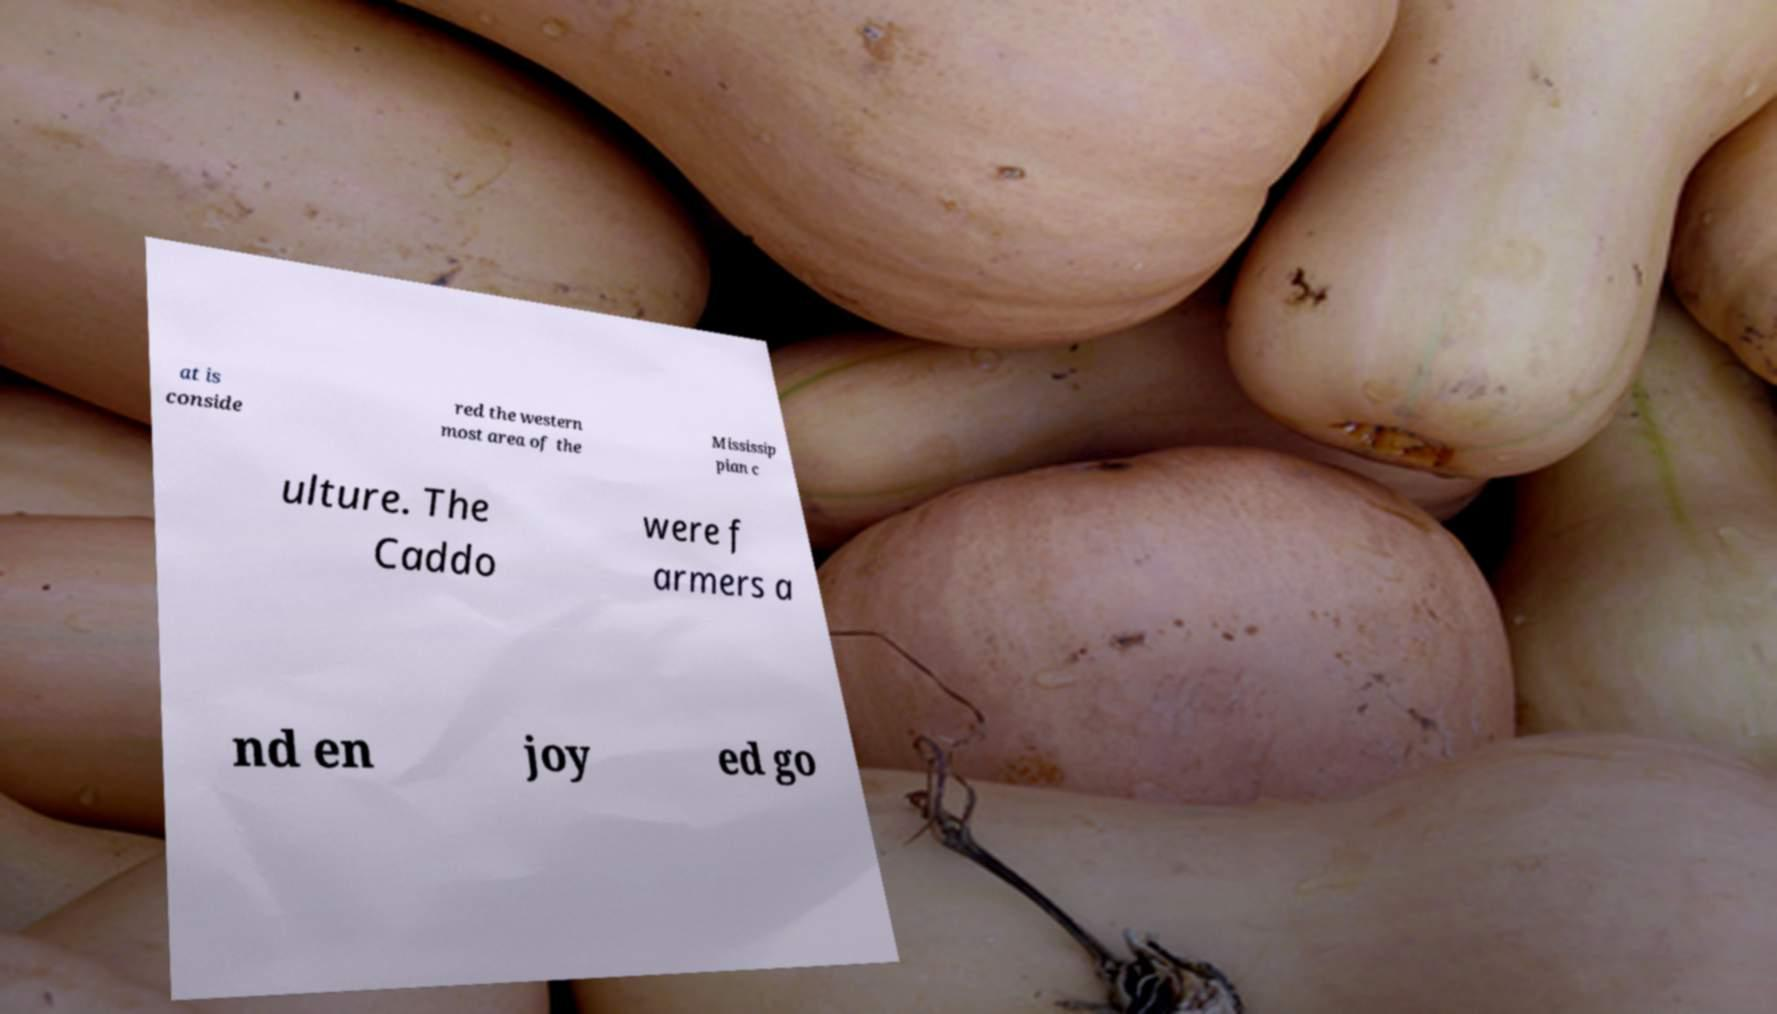Can you accurately transcribe the text from the provided image for me? at is conside red the western most area of the Mississip pian c ulture. The Caddo were f armers a nd en joy ed go 